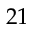Convert formula to latex. <formula><loc_0><loc_0><loc_500><loc_500>2 1</formula> 